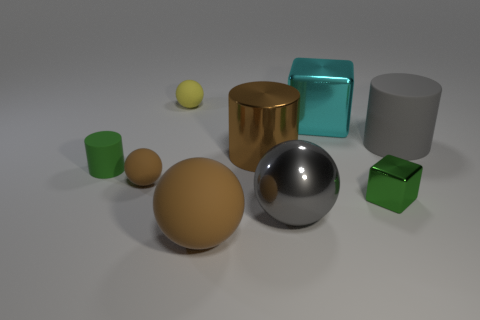Subtract all small brown rubber balls. How many balls are left? 3 Add 1 cyan objects. How many objects exist? 10 Subtract all yellow spheres. How many spheres are left? 3 Subtract all cylinders. How many objects are left? 6 Subtract 2 cubes. How many cubes are left? 0 Subtract all red blocks. Subtract all yellow spheres. How many blocks are left? 2 Subtract all purple balls. How many gray cylinders are left? 1 Subtract all small purple metallic cylinders. Subtract all shiny cubes. How many objects are left? 7 Add 3 gray metal spheres. How many gray metal spheres are left? 4 Add 5 big green metallic blocks. How many big green metallic blocks exist? 5 